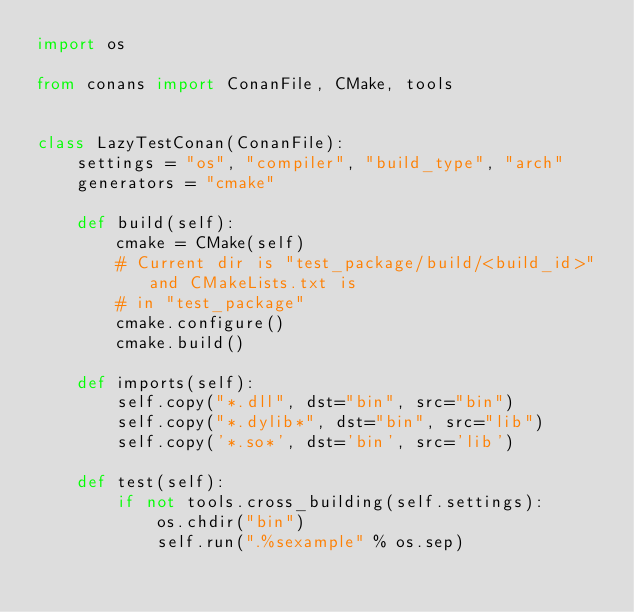Convert code to text. <code><loc_0><loc_0><loc_500><loc_500><_Python_>import os

from conans import ConanFile, CMake, tools


class LazyTestConan(ConanFile):
    settings = "os", "compiler", "build_type", "arch"
    generators = "cmake"

    def build(self):
        cmake = CMake(self)
        # Current dir is "test_package/build/<build_id>" and CMakeLists.txt is
        # in "test_package"
        cmake.configure()
        cmake.build()

    def imports(self):
        self.copy("*.dll", dst="bin", src="bin")
        self.copy("*.dylib*", dst="bin", src="lib")
        self.copy('*.so*', dst='bin', src='lib')

    def test(self):
        if not tools.cross_building(self.settings):
            os.chdir("bin")
            self.run(".%sexample" % os.sep)
</code> 